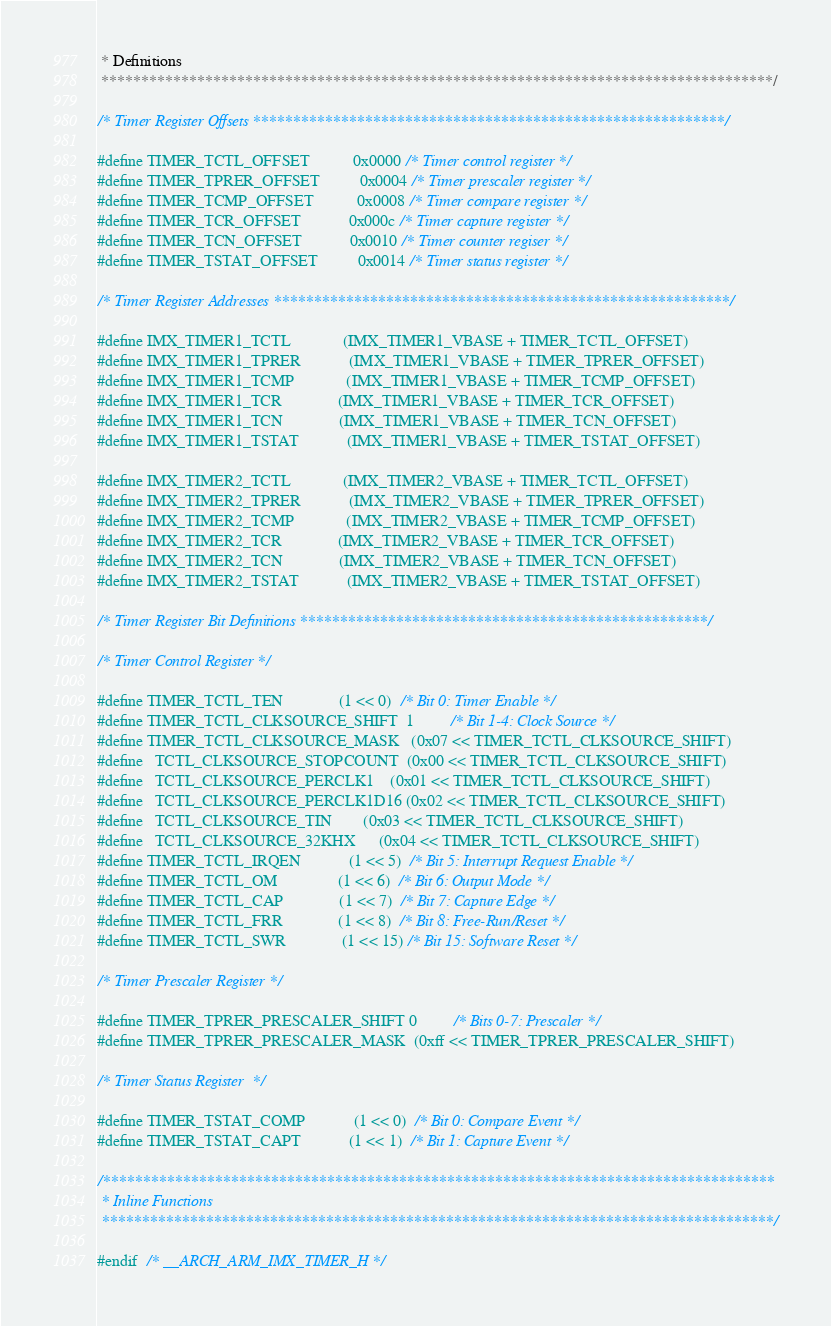<code> <loc_0><loc_0><loc_500><loc_500><_C_> * Definitions
 ************************************************************************************/

/* Timer Register Offsets ***********************************************************/

#define TIMER_TCTL_OFFSET           0x0000 /* Timer control register */
#define TIMER_TPRER_OFFSET          0x0004 /* Timer prescaler register */
#define TIMER_TCMP_OFFSET           0x0008 /* Timer compare register */
#define TIMER_TCR_OFFSET            0x000c /* Timer capture register */
#define TIMER_TCN_OFFSET            0x0010 /* Timer counter regiser */
#define TIMER_TSTAT_OFFSET          0x0014 /* Timer status register */

/* Timer Register Addresses *********************************************************/

#define IMX_TIMER1_TCTL             (IMX_TIMER1_VBASE + TIMER_TCTL_OFFSET)
#define IMX_TIMER1_TPRER            (IMX_TIMER1_VBASE + TIMER_TPRER_OFFSET)
#define IMX_TIMER1_TCMP             (IMX_TIMER1_VBASE + TIMER_TCMP_OFFSET)
#define IMX_TIMER1_TCR              (IMX_TIMER1_VBASE + TIMER_TCR_OFFSET)
#define IMX_TIMER1_TCN              (IMX_TIMER1_VBASE + TIMER_TCN_OFFSET)
#define IMX_TIMER1_TSTAT            (IMX_TIMER1_VBASE + TIMER_TSTAT_OFFSET)

#define IMX_TIMER2_TCTL             (IMX_TIMER2_VBASE + TIMER_TCTL_OFFSET)
#define IMX_TIMER2_TPRER            (IMX_TIMER2_VBASE + TIMER_TPRER_OFFSET)
#define IMX_TIMER2_TCMP             (IMX_TIMER2_VBASE + TIMER_TCMP_OFFSET)
#define IMX_TIMER2_TCR              (IMX_TIMER2_VBASE + TIMER_TCR_OFFSET)
#define IMX_TIMER2_TCN              (IMX_TIMER2_VBASE + TIMER_TCN_OFFSET)
#define IMX_TIMER2_TSTAT            (IMX_TIMER2_VBASE + TIMER_TSTAT_OFFSET)

/* Timer Register Bit Definitions ***************************************************/

/* Timer Control Register */

#define TIMER_TCTL_TEN              (1 << 0)  /* Bit 0: Timer Enable */
#define TIMER_TCTL_CLKSOURCE_SHIFT  1         /* Bit 1-4: Clock Source */
#define TIMER_TCTL_CLKSOURCE_MASK   (0x07 << TIMER_TCTL_CLKSOURCE_SHIFT)
#define   TCTL_CLKSOURCE_STOPCOUNT  (0x00 << TIMER_TCTL_CLKSOURCE_SHIFT)
#define   TCTL_CLKSOURCE_PERCLK1    (0x01 << TIMER_TCTL_CLKSOURCE_SHIFT)
#define   TCTL_CLKSOURCE_PERCLK1D16 (0x02 << TIMER_TCTL_CLKSOURCE_SHIFT)
#define   TCTL_CLKSOURCE_TIN        (0x03 << TIMER_TCTL_CLKSOURCE_SHIFT)
#define   TCTL_CLKSOURCE_32KHX      (0x04 << TIMER_TCTL_CLKSOURCE_SHIFT)
#define TIMER_TCTL_IRQEN            (1 << 5)  /* Bit 5: Interrupt Request Enable */
#define TIMER_TCTL_OM               (1 << 6)  /* Bit 6: Output Mode */
#define TIMER_TCTL_CAP              (1 << 7)  /* Bit 7: Capture Edge */
#define TIMER_TCTL_FRR              (1 << 8)  /* Bit 8: Free-Run/Reset */
#define TIMER_TCTL_SWR              (1 << 15) /* Bit 15: Software Reset */

/* Timer Prescaler Register */

#define TIMER_TPRER_PRESCALER_SHIFT 0         /* Bits 0-7: Prescaler */
#define TIMER_TPRER_PRESCALER_MASK  (0xff << TIMER_TPRER_PRESCALER_SHIFT)

/* Timer Status Register  */

#define TIMER_TSTAT_COMP            (1 << 0)  /* Bit 0: Compare Event */
#define TIMER_TSTAT_CAPT            (1 << 1)  /* Bit 1: Capture Event */

/************************************************************************************
 * Inline Functions
 ************************************************************************************/

#endif  /* __ARCH_ARM_IMX_TIMER_H */
</code> 